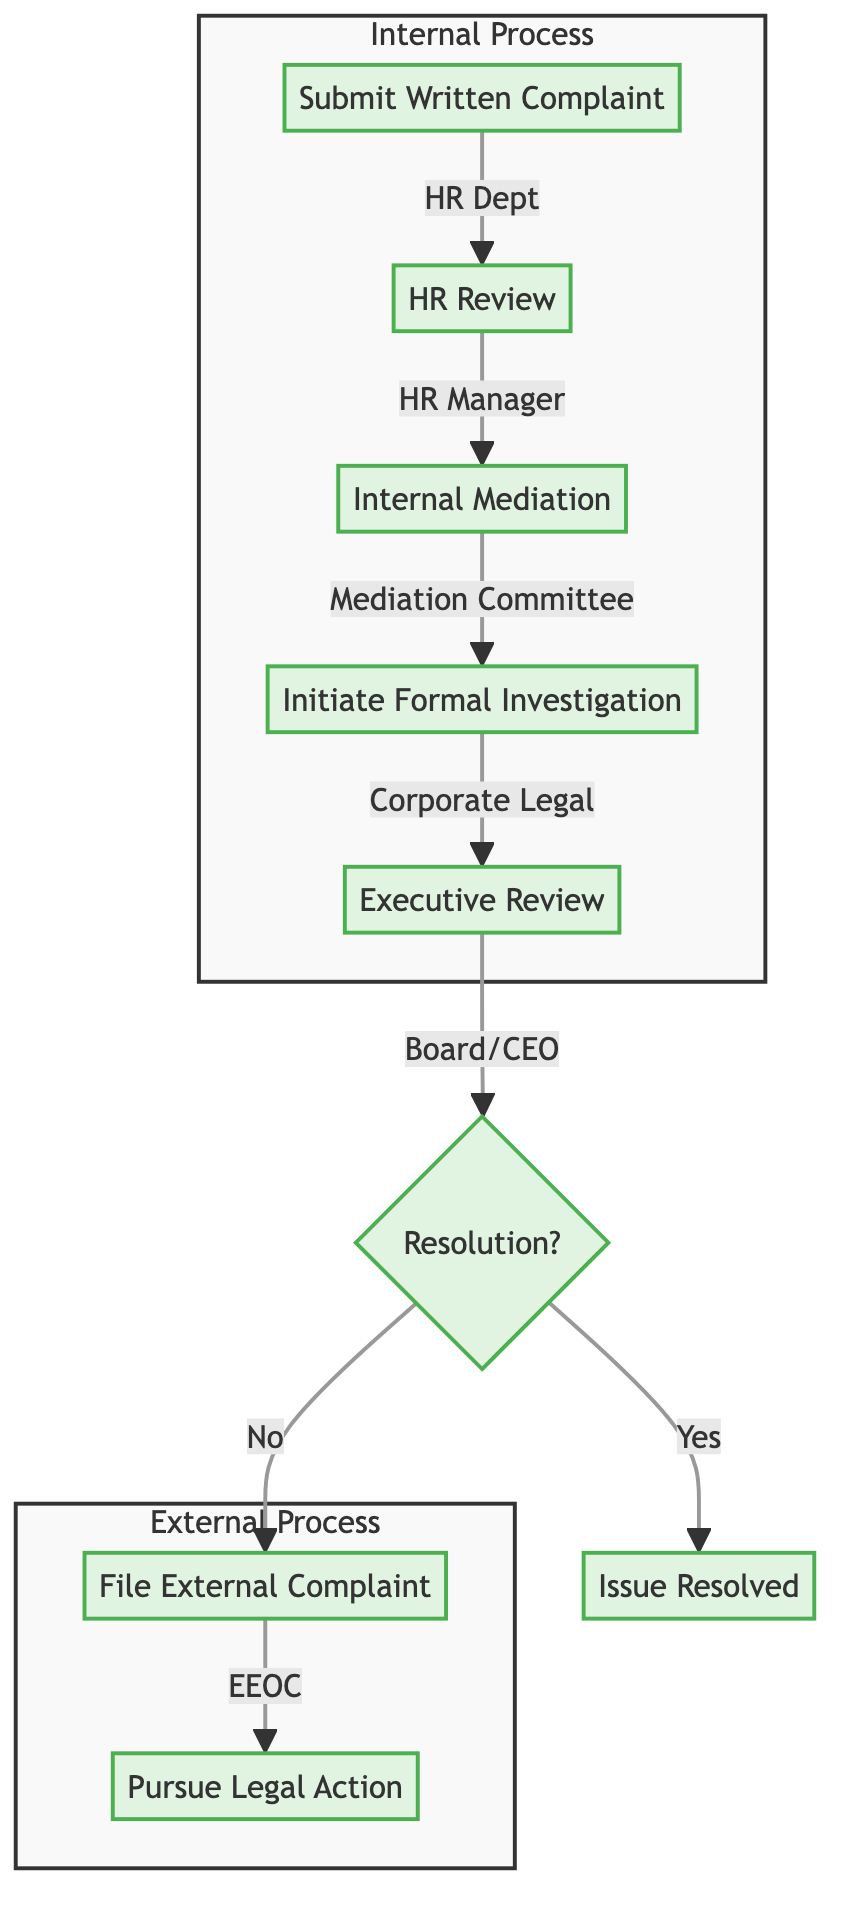What is the first step in the pay dispute process? The first step is "Submit Written Complaint," which is the starting point of the process, requiring an employee to document and present evidence of pay disparities.
Answer: Submit Written Complaint Which entity is responsible for the HR review? The entity responsible for the HR review is the "HR Manager," who conducts the initial assessment of the complaint submitted by Human Resources Department.
Answer: HR Manager How many steps are in the internal process? The internal process includes five steps, which are: Submit Written Complaint, HR Review, Internal Mediation, Initiate Formal Investigation, and Executive Review.
Answer: 5 What happens if the resolution is not achieved after the executive review? If the resolution is not achieved, the next step is to "File External Complaint," indicating that the internal processes did not resolve the pay dispute.
Answer: File External Complaint What is the final step if pursuing legal action? The final step if pursuing legal action is engaging with the "Court System," which allows the employee to seek justice and compensation through legal proceedings after all other options have been exhausted.
Answer: Court System Who facilitates the internal mediation process? The internal mediation process is facilitated by the "Mediation Committee," which includes representatives from both HR and Legal departments to attempt resolution.
Answer: Mediation Committee What decision does the Board of Directors or CEO make during the executive review? During the executive review, the Board of Directors or CEO reviews findings from the investigation and makes a decision on corrective actions based on the previous steps in the process.
Answer: Decision on corrective actions What occurs after filing a complaint with the EEOC? After filing a complaint with the EEOC, if the situation remains unresolved, the next course of action is to "Pursue Legal Action," indicating the potential escalation of the dispute beyond internal processes.
Answer: Pursue Legal Action 